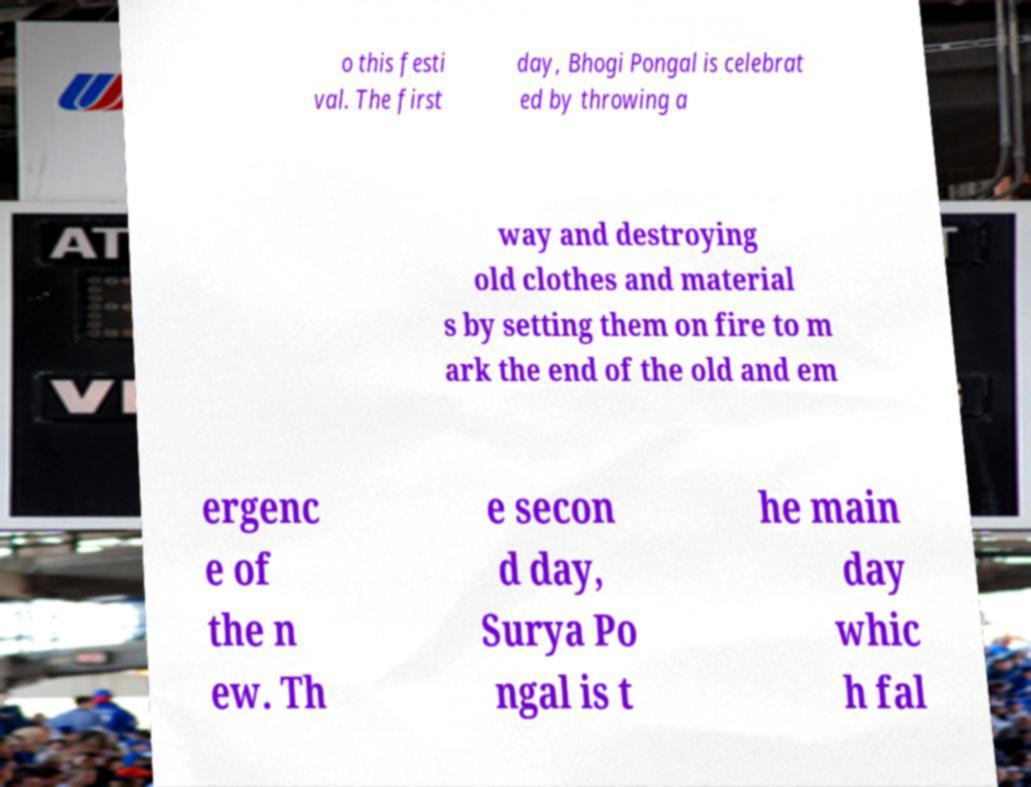Could you assist in decoding the text presented in this image and type it out clearly? o this festi val. The first day, Bhogi Pongal is celebrat ed by throwing a way and destroying old clothes and material s by setting them on fire to m ark the end of the old and em ergenc e of the n ew. Th e secon d day, Surya Po ngal is t he main day whic h fal 